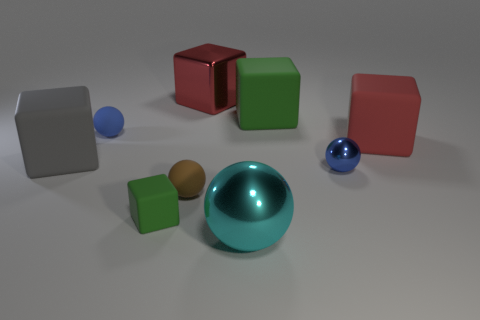Subtract all gray cubes. How many cubes are left? 4 Subtract all big metal blocks. How many blocks are left? 4 Subtract all yellow blocks. Subtract all cyan spheres. How many blocks are left? 5 Add 1 small green matte cubes. How many objects exist? 10 Subtract all cubes. How many objects are left? 4 Subtract all large objects. Subtract all gray blocks. How many objects are left? 3 Add 7 big red shiny objects. How many big red shiny objects are left? 8 Add 5 small shiny balls. How many small shiny balls exist? 6 Subtract 0 purple blocks. How many objects are left? 9 